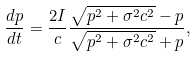Convert formula to latex. <formula><loc_0><loc_0><loc_500><loc_500>\frac { d p } { d t } = \frac { 2 I } { c } \frac { \sqrt { p ^ { 2 } + \sigma ^ { 2 } c ^ { 2 } } - p } { \sqrt { p ^ { 2 } + \sigma ^ { 2 } c ^ { 2 } } + p } ,</formula> 